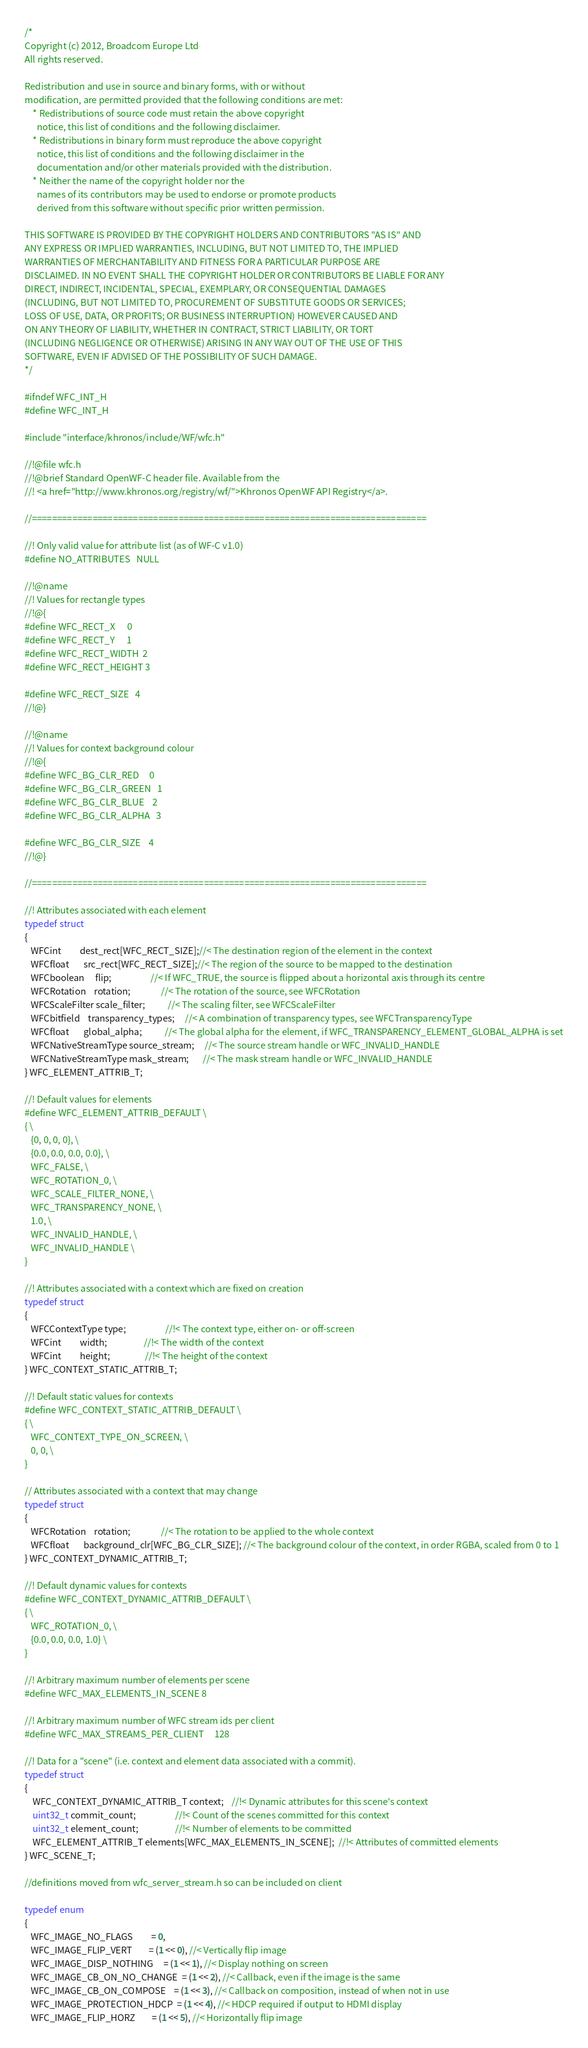Convert code to text. <code><loc_0><loc_0><loc_500><loc_500><_C_>/*
Copyright (c) 2012, Broadcom Europe Ltd
All rights reserved.

Redistribution and use in source and binary forms, with or without
modification, are permitted provided that the following conditions are met:
    * Redistributions of source code must retain the above copyright
      notice, this list of conditions and the following disclaimer.
    * Redistributions in binary form must reproduce the above copyright
      notice, this list of conditions and the following disclaimer in the
      documentation and/or other materials provided with the distribution.
    * Neither the name of the copyright holder nor the
      names of its contributors may be used to endorse or promote products
      derived from this software without specific prior written permission.

THIS SOFTWARE IS PROVIDED BY THE COPYRIGHT HOLDERS AND CONTRIBUTORS "AS IS" AND
ANY EXPRESS OR IMPLIED WARRANTIES, INCLUDING, BUT NOT LIMITED TO, THE IMPLIED
WARRANTIES OF MERCHANTABILITY AND FITNESS FOR A PARTICULAR PURPOSE ARE
DISCLAIMED. IN NO EVENT SHALL THE COPYRIGHT HOLDER OR CONTRIBUTORS BE LIABLE FOR ANY
DIRECT, INDIRECT, INCIDENTAL, SPECIAL, EXEMPLARY, OR CONSEQUENTIAL DAMAGES
(INCLUDING, BUT NOT LIMITED TO, PROCUREMENT OF SUBSTITUTE GOODS OR SERVICES;
LOSS OF USE, DATA, OR PROFITS; OR BUSINESS INTERRUPTION) HOWEVER CAUSED AND
ON ANY THEORY OF LIABILITY, WHETHER IN CONTRACT, STRICT LIABILITY, OR TORT
(INCLUDING NEGLIGENCE OR OTHERWISE) ARISING IN ANY WAY OUT OF THE USE OF THIS
SOFTWARE, EVEN IF ADVISED OF THE POSSIBILITY OF SUCH DAMAGE.
*/

#ifndef WFC_INT_H
#define WFC_INT_H

#include "interface/khronos/include/WF/wfc.h"

//!@file wfc.h
//!@brief Standard OpenWF-C header file. Available from the
//! <a href="http://www.khronos.org/registry/wf/">Khronos OpenWF API Registry</a>.

//==============================================================================

//! Only valid value for attribute list (as of WF-C v1.0)
#define NO_ATTRIBUTES   NULL

//!@name
//! Values for rectangle types
//!@{
#define WFC_RECT_X      0
#define WFC_RECT_Y      1
#define WFC_RECT_WIDTH  2
#define WFC_RECT_HEIGHT 3

#define WFC_RECT_SIZE   4
//!@}

//!@name
//! Values for context background colour
//!@{
#define WFC_BG_CLR_RED     0
#define WFC_BG_CLR_GREEN   1
#define WFC_BG_CLR_BLUE    2
#define WFC_BG_CLR_ALPHA   3

#define WFC_BG_CLR_SIZE    4
//!@}

//==============================================================================

//! Attributes associated with each element
typedef struct
{
   WFCint         dest_rect[WFC_RECT_SIZE];//< The destination region of the element in the context
   WFCfloat       src_rect[WFC_RECT_SIZE];//< The region of the source to be mapped to the destination
   WFCboolean     flip;                   //< If WFC_TRUE, the source is flipped about a horizontal axis through its centre
   WFCRotation    rotation;               //< The rotation of the source, see WFCRotation
   WFCScaleFilter scale_filter;           //< The scaling filter, see WFCScaleFilter
   WFCbitfield    transparency_types;     //< A combination of transparency types, see WFCTransparencyType
   WFCfloat       global_alpha;           //< The global alpha for the element, if WFC_TRANSPARENCY_ELEMENT_GLOBAL_ALPHA is set
   WFCNativeStreamType source_stream;     //< The source stream handle or WFC_INVALID_HANDLE
   WFCNativeStreamType mask_stream;       //< The mask stream handle or WFC_INVALID_HANDLE
} WFC_ELEMENT_ATTRIB_T;

//! Default values for elements
#define WFC_ELEMENT_ATTRIB_DEFAULT \
{ \
   {0, 0, 0, 0}, \
   {0.0, 0.0, 0.0, 0.0}, \
   WFC_FALSE, \
   WFC_ROTATION_0, \
   WFC_SCALE_FILTER_NONE, \
   WFC_TRANSPARENCY_NONE, \
   1.0, \
   WFC_INVALID_HANDLE, \
   WFC_INVALID_HANDLE \
}

//! Attributes associated with a context which are fixed on creation
typedef struct
{
   WFCContextType type;                   //!< The context type, either on- or off-screen
   WFCint         width;                  //!< The width of the context
   WFCint         height;                 //!< The height of the context
} WFC_CONTEXT_STATIC_ATTRIB_T;

//! Default static values for contexts
#define WFC_CONTEXT_STATIC_ATTRIB_DEFAULT \
{ \
   WFC_CONTEXT_TYPE_ON_SCREEN, \
   0, 0, \
}

// Attributes associated with a context that may change
typedef struct
{
   WFCRotation    rotation;               //< The rotation to be applied to the whole context
   WFCfloat       background_clr[WFC_BG_CLR_SIZE]; //< The background colour of the context, in order RGBA, scaled from 0 to 1
} WFC_CONTEXT_DYNAMIC_ATTRIB_T;

//! Default dynamic values for contexts
#define WFC_CONTEXT_DYNAMIC_ATTRIB_DEFAULT \
{ \
   WFC_ROTATION_0, \
   {0.0, 0.0, 0.0, 1.0} \
}

//! Arbitrary maximum number of elements per scene
#define WFC_MAX_ELEMENTS_IN_SCENE 8

//! Arbitrary maximum number of WFC stream ids per client
#define WFC_MAX_STREAMS_PER_CLIENT     128

//! Data for a "scene" (i.e. context and element data associated with a commit).
typedef struct
{
    WFC_CONTEXT_DYNAMIC_ATTRIB_T context;    //!< Dynamic attributes for this scene's context
    uint32_t commit_count;                   //!< Count of the scenes committed for this context
    uint32_t element_count;                  //!< Number of elements to be committed
    WFC_ELEMENT_ATTRIB_T elements[WFC_MAX_ELEMENTS_IN_SCENE];  //!< Attributes of committed elements
} WFC_SCENE_T;

//definitions moved from wfc_server_stream.h so can be included on client

typedef enum
{
   WFC_IMAGE_NO_FLAGS         = 0,
   WFC_IMAGE_FLIP_VERT        = (1 << 0), //< Vertically flip image
   WFC_IMAGE_DISP_NOTHING     = (1 << 1), //< Display nothing on screen
   WFC_IMAGE_CB_ON_NO_CHANGE  = (1 << 2), //< Callback, even if the image is the same
   WFC_IMAGE_CB_ON_COMPOSE    = (1 << 3), //< Callback on composition, instead of when not in use
   WFC_IMAGE_PROTECTION_HDCP  = (1 << 4), //< HDCP required if output to HDMI display
   WFC_IMAGE_FLIP_HORZ        = (1 << 5), //< Horizontally flip image</code> 